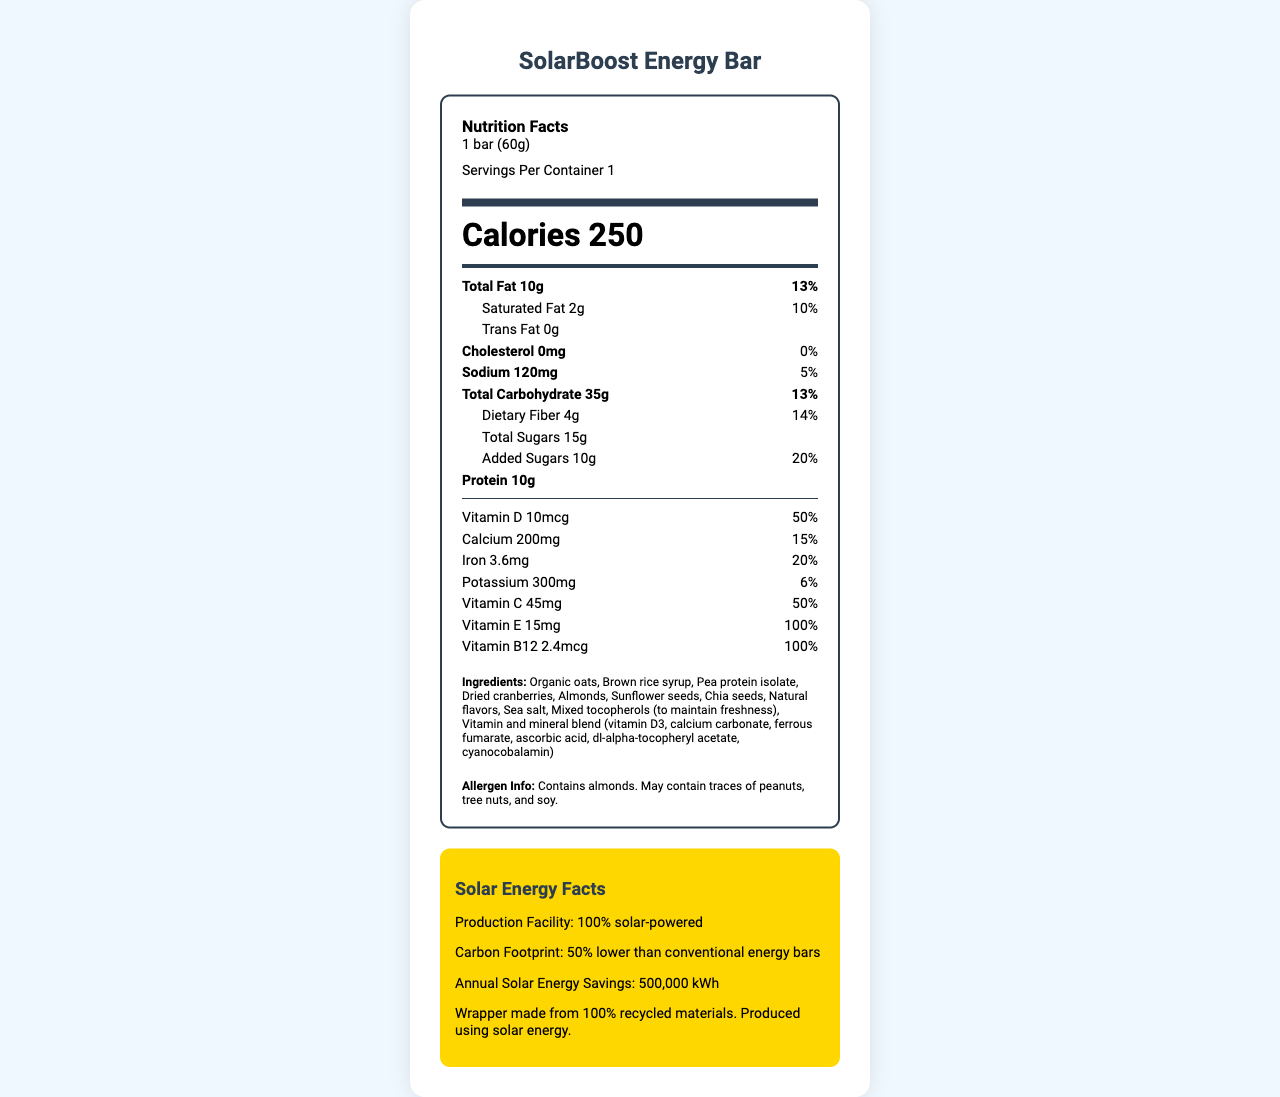what is the product name? The product name is clearly displayed at the top of the document.
Answer: SolarBoost Energy Bar what is the serving size of the SolarBoost Energy Bar? The serving size is listed in the "Nutrition Facts" section under "Serving Size".
Answer: 1 bar (60g) how many calories are in one serving of the SolarBoost Energy Bar? The number of calories per serving is prominently displayed in the "Calories" section.
Answer: 250 calories which ingredient is mentioned first in the list of ingredients? Organic oats are listed first in the ingredients list section.
Answer: Organic oats is the SolarBoost Energy Bar suitable for someone with a nut allergy? The allergen information states that the product contains almonds and may contain traces of peanuts, tree nuts, and soy.
Answer: No what is the percentage of daily value for total fat in one serving? The percentage daily value for total fat is indicated as 13% in the nutrition facts.
Answer: 13% how many grams of dietary fiber are in one serving of the SolarBoost Energy Bar? The amount of dietary fiber per serving is listed as 4g in the Nutrition Facts.
Answer: 4g how is the production facility of the SolarBoost Energy Bar powered? The Solar Energy Facts section states that the production facility is 100% solar-powered.
Answer: 100% solar-powered what is the cholesterol content in one serving of the SolarBoost Energy Bar? A. 0mg B. 5mg C. 10mg D. 15mg The cholesterol content is listed as 0mg in the Nutrition Facts.
Answer: A which vitamin has the highest percentage daily value in the SolarBoost Energy Bar? A. Vitamin D B. Vitamin E C. Vitamin C D. Vitamin B12 Vitamin E has a percentage daily value of 100%, the highest among the listed vitamins.
Answer: B are there any trans fats in the SolarBoost Energy Bar? The Nutrition Facts indicates that the trans fat content is 0g.
Answer: No summarize the key features of the SolarBoost Energy Bar as described in the document. The product combines nutritional value with an emphasis on sustainability and solar energy, making it suitable for endurance athletes and environmentally conscious consumers.
Answer: The SolarBoost Energy Bar is a 60g energy bar providing 250 calories per serving. It's rich in vitamins, particularly Vitamin E and B12, each with 100% daily value. It contains 10g of protein, 35g of carbohydrates, and 10g of total fat. The product is made with organic ingredients and is produced in a 100% solar-powered facility, emphasizing sustainability. what is the exact amount of added sugars in the SolarBoost Energy Bar? The Nutrition Facts identify added sugars specifically as 10g.
Answer: 10g what are the main benefits highlighted for the SolarBoost Energy Bar? These benefits are listed in the marketing claims section.
Answer: Powered by the sun, fueled by nature; Enhanced with vitamins for peak performance; Perfect for pre-competition energy boost; Scientifically formulated for endurance athletes what is the annual solar energy savings for the production of the SolarBoost Energy Bar? The Solar Energy Facts section states that the annual solar energy savings is 500,000 kWh.
Answer: 500,000 kWh does the document provide information about the price of the SolarBoost Energy Bar? The document includes various product features, ingredients, and nutritional information but does not mention the price.
Answer: Not enough information 